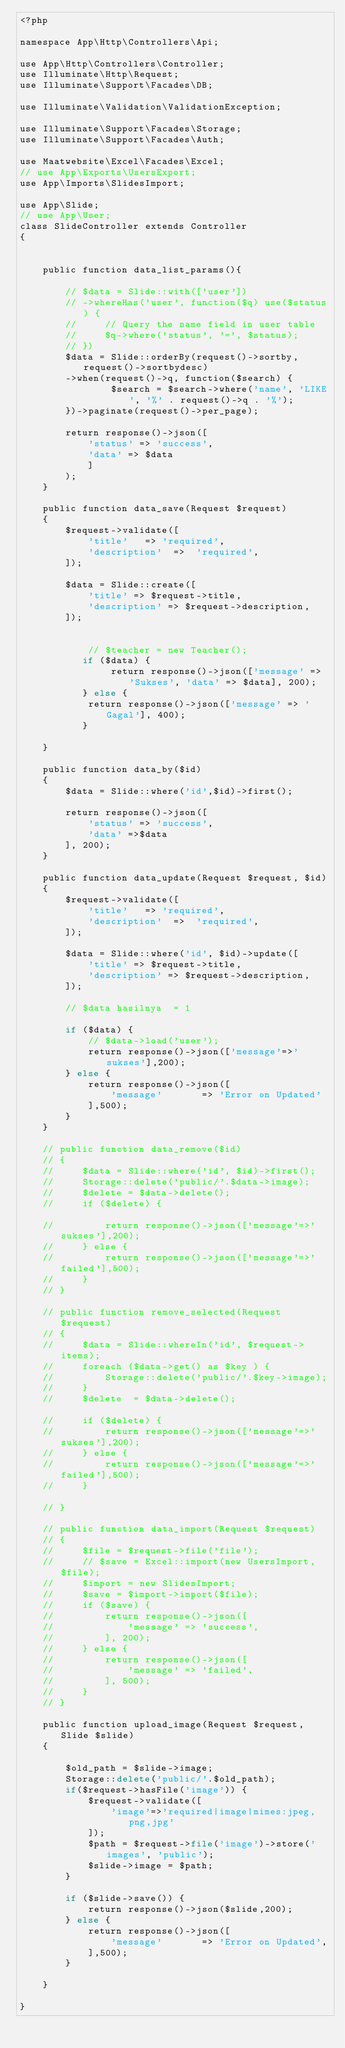<code> <loc_0><loc_0><loc_500><loc_500><_PHP_><?php

namespace App\Http\Controllers\Api;

use App\Http\Controllers\Controller;
use Illuminate\Http\Request;
use Illuminate\Support\Facades\DB;

use Illuminate\Validation\ValidationException;

use Illuminate\Support\Facades\Storage;
use Illuminate\Support\Facades\Auth;

use Maatwebsite\Excel\Facades\Excel;
// use App\Exports\UsersExport;
use App\Imports\SlidesImport;

use App\Slide;
// use App\User;
class SlideController extends Controller
{   
   

    public function data_list_params(){

        // $data = Slide::with(['user'])
        // ->whereHas('user', function($q) use($status) {
        //     // Query the name field in user table
        //     $q->where('status', '=', $status);
        // })
        $data = Slide::orderBy(request()->sortby, request()->sortbydesc)
        ->when(request()->q, function($search) {
                $search = $search->where('name', 'LIKE', '%' . request()->q . '%');
        })->paginate(request()->per_page); 

        return response()->json([
            'status' => 'success', 
            'data' => $data
            ]
        );
    }

    public function data_save(Request $request)
    {
        $request->validate([
            'title'   => 'required',
            'description'  =>  'required',
        ]);
        
        $data = Slide::create([
            'title' => $request->title,
            'description' => $request->description,
        ]);

       
            // $teacher = new Teacher();
           if ($data) {
                return response()->json(['message' => 'Sukses', 'data' => $data], 200);
           } else {
            return response()->json(['message' => 'Gagal'], 400);
           }

    }

    public function data_by($id)
    {
        $data = Slide::where('id',$id)->first();
       
        return response()->json([
            'status' => 'success',
            'data' =>$data
        ], 200);
    }

    public function data_update(Request $request, $id)
    {
        $request->validate([
            'title'   => 'required',
            'description'  =>  'required',
        ]);

        $data = Slide::where('id', $id)->update([
            'title' => $request->title,
            'description' => $request->description,
        ]);

        // $data hasilnya  = 1

        if ($data) {
            // $data->load('user');
            return response()->json(['message'=>'sukses'],200);
        } else {
            return response()->json([
                'message'       => 'Error on Updated'
            ],500);
        } 
    }

    // public function data_remove($id)
    // {
    //     $data = Slide::where('id', $id)->first();
    //     Storage::delete('public/'.$data->image);
    //     $delete = $data->delete();
    //     if ($delete) {
            
    //         return response()->json(['message'=>'sukses'],200);
    //     } else {
    //         return response()->json(['message'=>'failed'],500);
    //     }
    // }

    // public function remove_selected(Request $request)
    // {   
    //     $data = Slide::whereIn('id', $request->items);
    //     foreach ($data->get() as $key ) {
    //         Storage::delete('public/'.$key->image);
    //     }
    //     $delete  = $data->delete();
        
    //     if ($delete) {
    //         return response()->json(['message'=>'sukses'],200);
    //     } else {
    //         return response()->json(['message'=>'failed'],500);
    //     }
        
    // }

    // public function data_import(Request $request)
    // {
    //     $file = $request->file('file');
    //     // $save = Excel::import(new UsersImport, $file);
    //     $import = new SlidesImport;
    //     $save = $import->import($file);
    //     if ($save) {
    //         return response()->json([
    //             'message' => 'success',
    //         ], 200);
    //     } else {
    //         return response()->json([
    //             'message' => 'failed',
    //         ], 500);
    //     }
    // }

    public function upload_image(Request $request, Slide $slide)
    {

        $old_path = $slide->image;
        Storage::delete('public/'.$old_path);
        if($request->hasFile('image')) {
            $request->validate([
                'image'=>'required|image|mimes:jpeg,png,jpg'
            ]);
            $path = $request->file('image')->store('images', 'public');
            $slide->image = $path;
        }
       
        if ($slide->save()) {
            return response()->json($slide,200);
        } else {
            return response()->json([
                'message'       => 'Error on Updated',
            ],500);
        } 

    }

}
</code> 